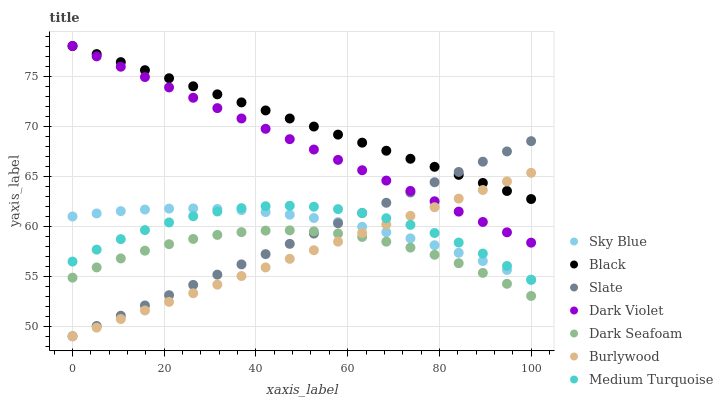Does Burlywood have the minimum area under the curve?
Answer yes or no. Yes. Does Black have the maximum area under the curve?
Answer yes or no. Yes. Does Slate have the minimum area under the curve?
Answer yes or no. No. Does Slate have the maximum area under the curve?
Answer yes or no. No. Is Slate the smoothest?
Answer yes or no. Yes. Is Medium Turquoise the roughest?
Answer yes or no. Yes. Is Dark Violet the smoothest?
Answer yes or no. No. Is Dark Violet the roughest?
Answer yes or no. No. Does Burlywood have the lowest value?
Answer yes or no. Yes. Does Dark Violet have the lowest value?
Answer yes or no. No. Does Black have the highest value?
Answer yes or no. Yes. Does Slate have the highest value?
Answer yes or no. No. Is Sky Blue less than Dark Violet?
Answer yes or no. Yes. Is Sky Blue greater than Dark Seafoam?
Answer yes or no. Yes. Does Sky Blue intersect Slate?
Answer yes or no. Yes. Is Sky Blue less than Slate?
Answer yes or no. No. Is Sky Blue greater than Slate?
Answer yes or no. No. Does Sky Blue intersect Dark Violet?
Answer yes or no. No. 